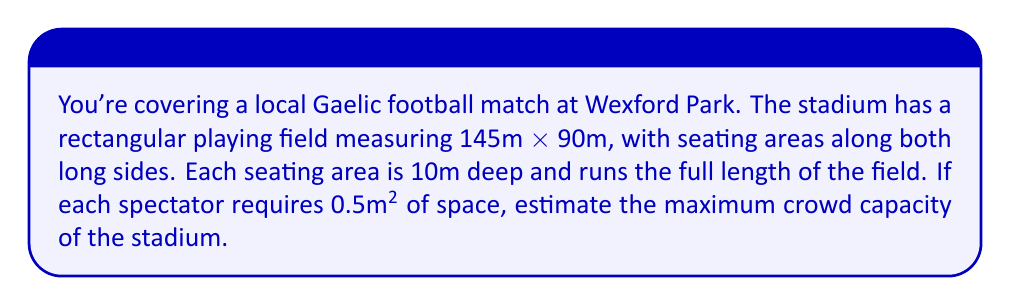Solve this math problem. Let's approach this step-by-step:

1. Calculate the area of the seating sections:
   - Length of each section: 145m (same as field length)
   - Depth of each section: 10m
   - Area of one section: $145m \times 10m = 1450m²$
   - Total seating area: $1450m² \times 2 = 2900m²$

2. Calculate the number of spectators that can fit in this area:
   - Each spectator requires 0.5m² of space
   - Number of spectators = Total area / Space per spectator
   - $N = \frac{2900m²}{0.5m²/person} = 5800$ people

3. Round to a reasonable estimate:
   Given that this is an estimate and we need to account for walkways, entrances, and other spaces, it's appropriate to round down to the nearest hundred.

Therefore, the estimated maximum crowd capacity is 5800 people, rounded down to 5700 for a more conservative estimate.
Answer: 5700 spectators 